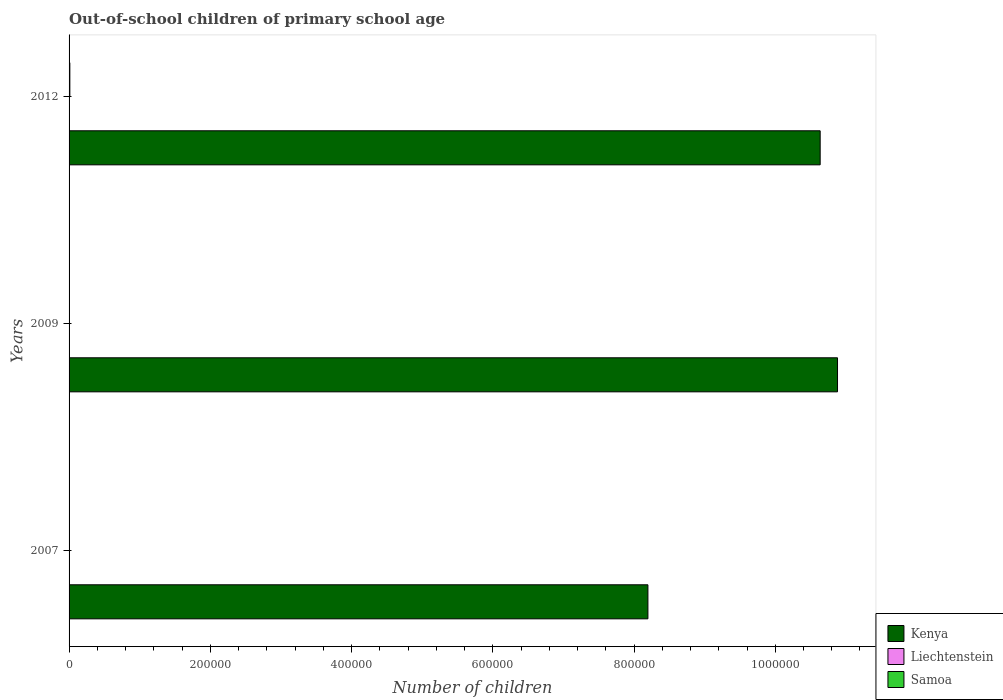How many different coloured bars are there?
Your response must be concise. 3. Are the number of bars on each tick of the Y-axis equal?
Offer a terse response. Yes. How many bars are there on the 1st tick from the top?
Your response must be concise. 3. How many bars are there on the 2nd tick from the bottom?
Your answer should be compact. 3. In how many cases, is the number of bars for a given year not equal to the number of legend labels?
Your answer should be compact. 0. Across all years, what is the minimum number of out-of-school children in Kenya?
Your response must be concise. 8.20e+05. What is the total number of out-of-school children in Kenya in the graph?
Ensure brevity in your answer.  2.97e+06. What is the difference between the number of out-of-school children in Samoa in 2007 and that in 2012?
Your answer should be compact. -647. What is the difference between the number of out-of-school children in Kenya in 2009 and the number of out-of-school children in Liechtenstein in 2012?
Make the answer very short. 1.09e+06. What is the average number of out-of-school children in Samoa per year?
Your response must be concise. 544. In the year 2009, what is the difference between the number of out-of-school children in Samoa and number of out-of-school children in Liechtenstein?
Give a very brief answer. 43. What is the ratio of the number of out-of-school children in Liechtenstein in 2009 to that in 2012?
Provide a succinct answer. 1.03. Is the number of out-of-school children in Samoa in 2009 less than that in 2012?
Give a very brief answer. Yes. What is the difference between the highest and the second highest number of out-of-school children in Samoa?
Offer a very short reply. 647. What is the difference between the highest and the lowest number of out-of-school children in Samoa?
Offer a very short reply. 1030. In how many years, is the number of out-of-school children in Kenya greater than the average number of out-of-school children in Kenya taken over all years?
Keep it short and to the point. 2. Is the sum of the number of out-of-school children in Kenya in 2007 and 2012 greater than the maximum number of out-of-school children in Liechtenstein across all years?
Provide a succinct answer. Yes. What does the 2nd bar from the top in 2007 represents?
Ensure brevity in your answer.  Liechtenstein. What does the 1st bar from the bottom in 2009 represents?
Make the answer very short. Kenya. How many years are there in the graph?
Your answer should be compact. 3. Where does the legend appear in the graph?
Your answer should be very brief. Bottom right. What is the title of the graph?
Offer a very short reply. Out-of-school children of primary school age. What is the label or title of the X-axis?
Ensure brevity in your answer.  Number of children. What is the label or title of the Y-axis?
Give a very brief answer. Years. What is the Number of children in Kenya in 2007?
Provide a succinct answer. 8.20e+05. What is the Number of children of Samoa in 2007?
Make the answer very short. 456. What is the Number of children of Kenya in 2009?
Keep it short and to the point. 1.09e+06. What is the Number of children of Liechtenstein in 2009?
Provide a succinct answer. 30. What is the Number of children in Samoa in 2009?
Ensure brevity in your answer.  73. What is the Number of children in Kenya in 2012?
Make the answer very short. 1.06e+06. What is the Number of children of Liechtenstein in 2012?
Give a very brief answer. 29. What is the Number of children in Samoa in 2012?
Make the answer very short. 1103. Across all years, what is the maximum Number of children in Kenya?
Ensure brevity in your answer.  1.09e+06. Across all years, what is the maximum Number of children in Samoa?
Give a very brief answer. 1103. Across all years, what is the minimum Number of children of Kenya?
Give a very brief answer. 8.20e+05. Across all years, what is the minimum Number of children of Liechtenstein?
Provide a short and direct response. 23. What is the total Number of children of Kenya in the graph?
Offer a terse response. 2.97e+06. What is the total Number of children in Liechtenstein in the graph?
Your response must be concise. 82. What is the total Number of children of Samoa in the graph?
Offer a very short reply. 1632. What is the difference between the Number of children in Kenya in 2007 and that in 2009?
Offer a very short reply. -2.68e+05. What is the difference between the Number of children of Liechtenstein in 2007 and that in 2009?
Your response must be concise. -7. What is the difference between the Number of children in Samoa in 2007 and that in 2009?
Ensure brevity in your answer.  383. What is the difference between the Number of children in Kenya in 2007 and that in 2012?
Your answer should be very brief. -2.44e+05. What is the difference between the Number of children in Liechtenstein in 2007 and that in 2012?
Your answer should be compact. -6. What is the difference between the Number of children of Samoa in 2007 and that in 2012?
Provide a succinct answer. -647. What is the difference between the Number of children of Kenya in 2009 and that in 2012?
Make the answer very short. 2.45e+04. What is the difference between the Number of children in Liechtenstein in 2009 and that in 2012?
Make the answer very short. 1. What is the difference between the Number of children of Samoa in 2009 and that in 2012?
Your answer should be compact. -1030. What is the difference between the Number of children in Kenya in 2007 and the Number of children in Liechtenstein in 2009?
Your response must be concise. 8.20e+05. What is the difference between the Number of children in Kenya in 2007 and the Number of children in Samoa in 2009?
Offer a very short reply. 8.20e+05. What is the difference between the Number of children in Kenya in 2007 and the Number of children in Liechtenstein in 2012?
Offer a terse response. 8.20e+05. What is the difference between the Number of children of Kenya in 2007 and the Number of children of Samoa in 2012?
Offer a terse response. 8.19e+05. What is the difference between the Number of children of Liechtenstein in 2007 and the Number of children of Samoa in 2012?
Your answer should be very brief. -1080. What is the difference between the Number of children in Kenya in 2009 and the Number of children in Liechtenstein in 2012?
Your response must be concise. 1.09e+06. What is the difference between the Number of children in Kenya in 2009 and the Number of children in Samoa in 2012?
Offer a very short reply. 1.09e+06. What is the difference between the Number of children in Liechtenstein in 2009 and the Number of children in Samoa in 2012?
Your answer should be compact. -1073. What is the average Number of children in Kenya per year?
Keep it short and to the point. 9.90e+05. What is the average Number of children of Liechtenstein per year?
Offer a terse response. 27.33. What is the average Number of children in Samoa per year?
Make the answer very short. 544. In the year 2007, what is the difference between the Number of children in Kenya and Number of children in Liechtenstein?
Provide a short and direct response. 8.20e+05. In the year 2007, what is the difference between the Number of children of Kenya and Number of children of Samoa?
Your answer should be very brief. 8.19e+05. In the year 2007, what is the difference between the Number of children of Liechtenstein and Number of children of Samoa?
Offer a terse response. -433. In the year 2009, what is the difference between the Number of children in Kenya and Number of children in Liechtenstein?
Offer a very short reply. 1.09e+06. In the year 2009, what is the difference between the Number of children in Kenya and Number of children in Samoa?
Ensure brevity in your answer.  1.09e+06. In the year 2009, what is the difference between the Number of children in Liechtenstein and Number of children in Samoa?
Provide a succinct answer. -43. In the year 2012, what is the difference between the Number of children of Kenya and Number of children of Liechtenstein?
Keep it short and to the point. 1.06e+06. In the year 2012, what is the difference between the Number of children in Kenya and Number of children in Samoa?
Your answer should be compact. 1.06e+06. In the year 2012, what is the difference between the Number of children of Liechtenstein and Number of children of Samoa?
Provide a succinct answer. -1074. What is the ratio of the Number of children of Kenya in 2007 to that in 2009?
Give a very brief answer. 0.75. What is the ratio of the Number of children in Liechtenstein in 2007 to that in 2009?
Provide a short and direct response. 0.77. What is the ratio of the Number of children of Samoa in 2007 to that in 2009?
Ensure brevity in your answer.  6.25. What is the ratio of the Number of children in Kenya in 2007 to that in 2012?
Give a very brief answer. 0.77. What is the ratio of the Number of children in Liechtenstein in 2007 to that in 2012?
Make the answer very short. 0.79. What is the ratio of the Number of children of Samoa in 2007 to that in 2012?
Offer a very short reply. 0.41. What is the ratio of the Number of children of Kenya in 2009 to that in 2012?
Provide a succinct answer. 1.02. What is the ratio of the Number of children of Liechtenstein in 2009 to that in 2012?
Offer a very short reply. 1.03. What is the ratio of the Number of children in Samoa in 2009 to that in 2012?
Your answer should be compact. 0.07. What is the difference between the highest and the second highest Number of children in Kenya?
Offer a terse response. 2.45e+04. What is the difference between the highest and the second highest Number of children of Liechtenstein?
Keep it short and to the point. 1. What is the difference between the highest and the second highest Number of children of Samoa?
Keep it short and to the point. 647. What is the difference between the highest and the lowest Number of children in Kenya?
Your answer should be very brief. 2.68e+05. What is the difference between the highest and the lowest Number of children of Samoa?
Keep it short and to the point. 1030. 